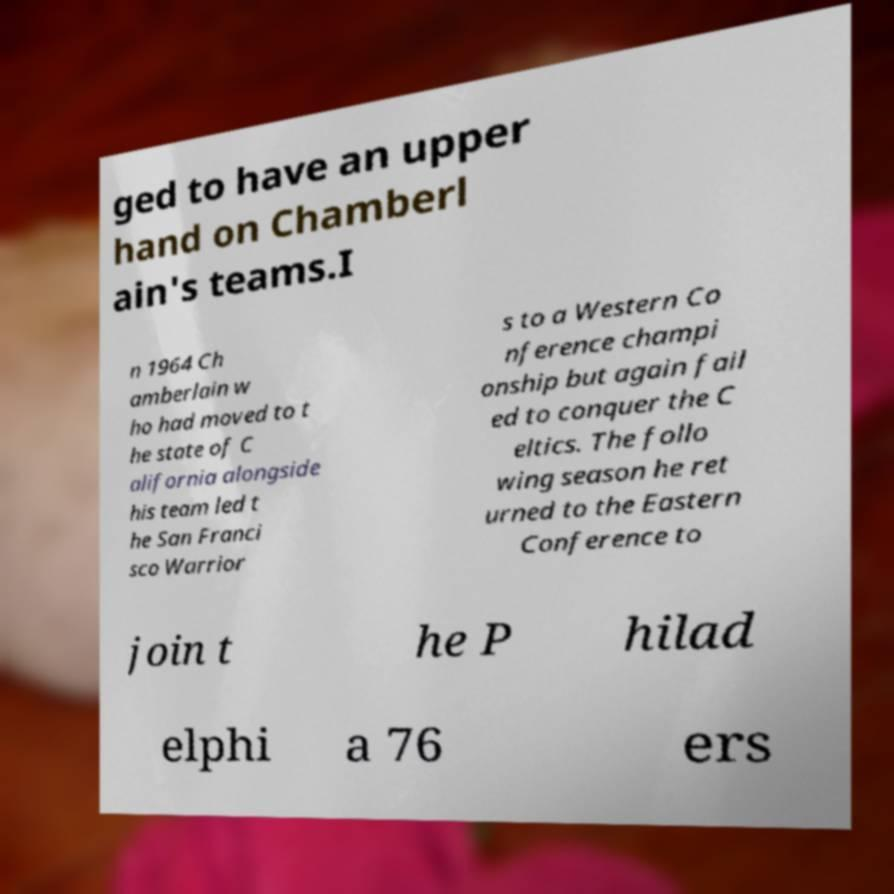There's text embedded in this image that I need extracted. Can you transcribe it verbatim? ged to have an upper hand on Chamberl ain's teams.I n 1964 Ch amberlain w ho had moved to t he state of C alifornia alongside his team led t he San Franci sco Warrior s to a Western Co nference champi onship but again fail ed to conquer the C eltics. The follo wing season he ret urned to the Eastern Conference to join t he P hilad elphi a 76 ers 